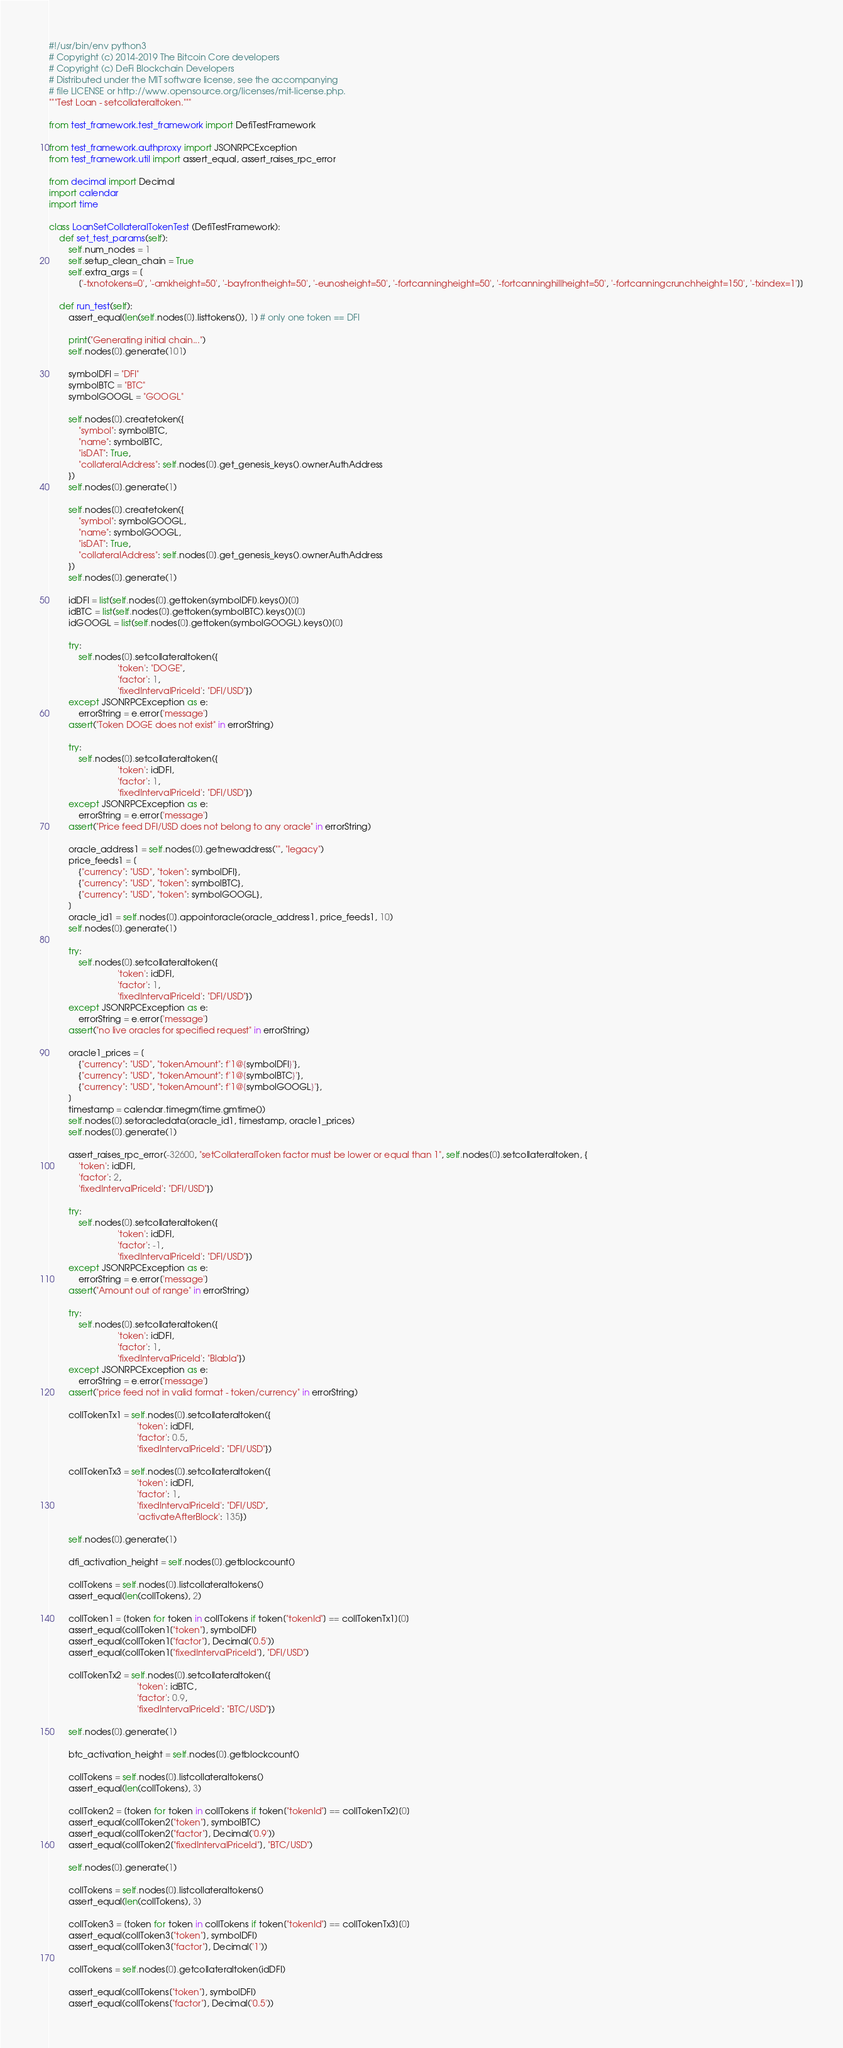Convert code to text. <code><loc_0><loc_0><loc_500><loc_500><_Python_>#!/usr/bin/env python3
# Copyright (c) 2014-2019 The Bitcoin Core developers
# Copyright (c) DeFi Blockchain Developers
# Distributed under the MIT software license, see the accompanying
# file LICENSE or http://www.opensource.org/licenses/mit-license.php.
"""Test Loan - setcollateraltoken."""

from test_framework.test_framework import DefiTestFramework

from test_framework.authproxy import JSONRPCException
from test_framework.util import assert_equal, assert_raises_rpc_error

from decimal import Decimal
import calendar
import time

class LoanSetCollateralTokenTest (DefiTestFramework):
    def set_test_params(self):
        self.num_nodes = 1
        self.setup_clean_chain = True
        self.extra_args = [
            ['-txnotokens=0', '-amkheight=50', '-bayfrontheight=50', '-eunosheight=50', '-fortcanningheight=50', '-fortcanninghillheight=50', '-fortcanningcrunchheight=150', '-txindex=1']]

    def run_test(self):
        assert_equal(len(self.nodes[0].listtokens()), 1) # only one token == DFI

        print("Generating initial chain...")
        self.nodes[0].generate(101)

        symbolDFI = "DFI"
        symbolBTC = "BTC"
        symbolGOOGL = "GOOGL"

        self.nodes[0].createtoken({
            "symbol": symbolBTC,
            "name": symbolBTC,
            "isDAT": True,
            "collateralAddress": self.nodes[0].get_genesis_keys().ownerAuthAddress
        })
        self.nodes[0].generate(1)

        self.nodes[0].createtoken({
            "symbol": symbolGOOGL,
            "name": symbolGOOGL,
            "isDAT": True,
            "collateralAddress": self.nodes[0].get_genesis_keys().ownerAuthAddress
        })
        self.nodes[0].generate(1)

        idDFI = list(self.nodes[0].gettoken(symbolDFI).keys())[0]
        idBTC = list(self.nodes[0].gettoken(symbolBTC).keys())[0]
        idGOOGL = list(self.nodes[0].gettoken(symbolGOOGL).keys())[0]

        try:
            self.nodes[0].setcollateraltoken({
                            'token': "DOGE",
                            'factor': 1,
                            'fixedIntervalPriceId': "DFI/USD"})
        except JSONRPCException as e:
            errorString = e.error['message']
        assert("Token DOGE does not exist" in errorString)

        try:
            self.nodes[0].setcollateraltoken({
                            'token': idDFI,
                            'factor': 1,
                            'fixedIntervalPriceId': "DFI/USD"})
        except JSONRPCException as e:
            errorString = e.error['message']
        assert("Price feed DFI/USD does not belong to any oracle" in errorString)

        oracle_address1 = self.nodes[0].getnewaddress("", "legacy")
        price_feeds1 = [
            {"currency": "USD", "token": symbolDFI},
            {"currency": "USD", "token": symbolBTC},
            {"currency": "USD", "token": symbolGOOGL},
        ]
        oracle_id1 = self.nodes[0].appointoracle(oracle_address1, price_feeds1, 10)
        self.nodes[0].generate(1)

        try:
            self.nodes[0].setcollateraltoken({
                            'token': idDFI,
                            'factor': 1,
                            'fixedIntervalPriceId': "DFI/USD"})
        except JSONRPCException as e:
            errorString = e.error['message']
        assert("no live oracles for specified request" in errorString)

        oracle1_prices = [
            {"currency": "USD", "tokenAmount": f'1@{symbolDFI}'},
            {"currency": "USD", "tokenAmount": f'1@{symbolBTC}'},
            {"currency": "USD", "tokenAmount": f'1@{symbolGOOGL}'},
        ]
        timestamp = calendar.timegm(time.gmtime())
        self.nodes[0].setoracledata(oracle_id1, timestamp, oracle1_prices)
        self.nodes[0].generate(1)

        assert_raises_rpc_error(-32600, "setCollateralToken factor must be lower or equal than 1", self.nodes[0].setcollateraltoken, {
            'token': idDFI,
            'factor': 2,
            'fixedIntervalPriceId': "DFI/USD"})

        try:
            self.nodes[0].setcollateraltoken({
                            'token': idDFI,
                            'factor': -1,
                            'fixedIntervalPriceId': "DFI/USD"})
        except JSONRPCException as e:
            errorString = e.error['message']
        assert("Amount out of range" in errorString)

        try:
            self.nodes[0].setcollateraltoken({
                            'token': idDFI,
                            'factor': 1,
                            'fixedIntervalPriceId': "Blabla"})
        except JSONRPCException as e:
            errorString = e.error['message']
        assert("price feed not in valid format - token/currency" in errorString)

        collTokenTx1 = self.nodes[0].setcollateraltoken({
                                    'token': idDFI,
                                    'factor': 0.5,
                                    'fixedIntervalPriceId': "DFI/USD"})

        collTokenTx3 = self.nodes[0].setcollateraltoken({
                                    'token': idDFI,
                                    'factor': 1,
                                    'fixedIntervalPriceId': "DFI/USD",
                                    'activateAfterBlock': 135})

        self.nodes[0].generate(1)

        dfi_activation_height = self.nodes[0].getblockcount()

        collTokens = self.nodes[0].listcollateraltokens()
        assert_equal(len(collTokens), 2)

        collToken1 = [token for token in collTokens if token["tokenId"] == collTokenTx1][0]
        assert_equal(collToken1["token"], symbolDFI)
        assert_equal(collToken1["factor"], Decimal('0.5'))
        assert_equal(collToken1["fixedIntervalPriceId"], "DFI/USD")

        collTokenTx2 = self.nodes[0].setcollateraltoken({
                                    'token': idBTC,
                                    'factor': 0.9,
                                    'fixedIntervalPriceId': "BTC/USD"})

        self.nodes[0].generate(1)

        btc_activation_height = self.nodes[0].getblockcount()

        collTokens = self.nodes[0].listcollateraltokens()
        assert_equal(len(collTokens), 3)

        collToken2 = [token for token in collTokens if token["tokenId"] == collTokenTx2][0]
        assert_equal(collToken2["token"], symbolBTC)
        assert_equal(collToken2["factor"], Decimal('0.9'))
        assert_equal(collToken2["fixedIntervalPriceId"], "BTC/USD")

        self.nodes[0].generate(1)

        collTokens = self.nodes[0].listcollateraltokens()
        assert_equal(len(collTokens), 3)

        collToken3 = [token for token in collTokens if token["tokenId"] == collTokenTx3][0]
        assert_equal(collToken3["token"], symbolDFI)
        assert_equal(collToken3["factor"], Decimal('1'))

        collTokens = self.nodes[0].getcollateraltoken(idDFI)

        assert_equal(collTokens["token"], symbolDFI)
        assert_equal(collTokens["factor"], Decimal('0.5'))</code> 